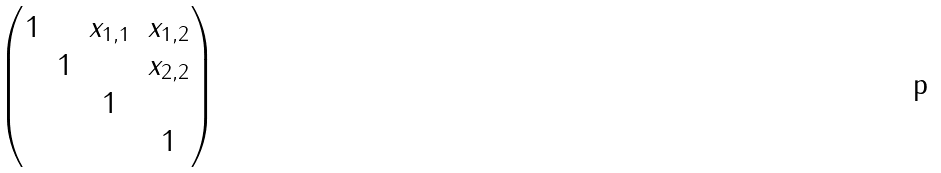<formula> <loc_0><loc_0><loc_500><loc_500>\begin{pmatrix} 1 & & x _ { 1 , 1 } & x _ { 1 , 2 } \\ & 1 & & x _ { 2 , 2 } \\ & & 1 & \\ & & & 1 \end{pmatrix}</formula> 